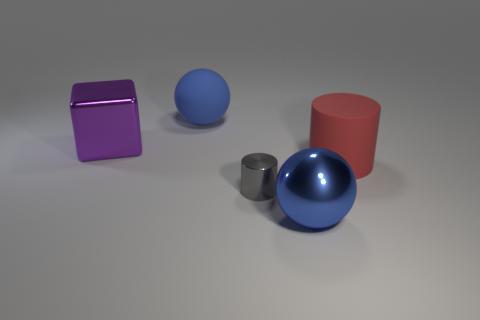Add 3 tiny blue cylinders. How many objects exist? 8 Subtract all cylinders. How many objects are left? 3 Subtract all large red matte cylinders. Subtract all big green shiny cylinders. How many objects are left? 4 Add 4 red cylinders. How many red cylinders are left? 5 Add 4 small gray shiny cylinders. How many small gray shiny cylinders exist? 5 Subtract 0 green blocks. How many objects are left? 5 